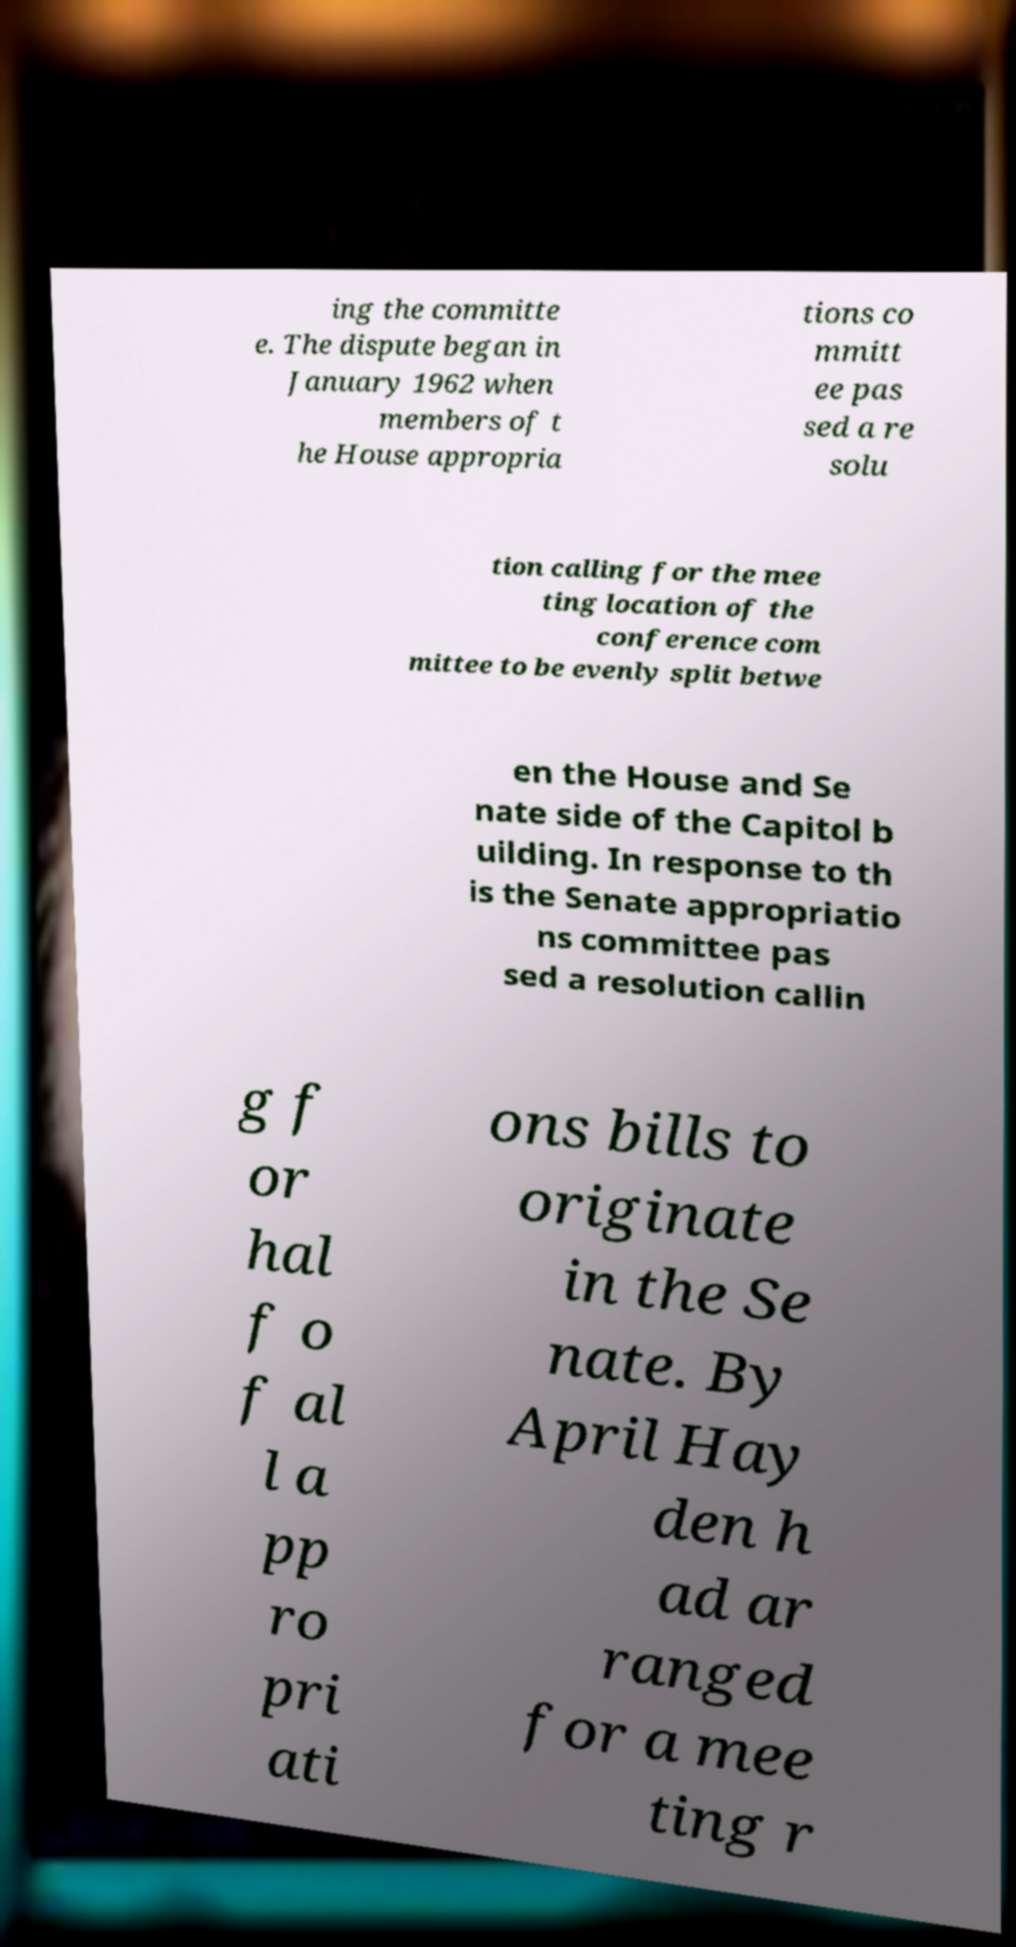There's text embedded in this image that I need extracted. Can you transcribe it verbatim? ing the committe e. The dispute began in January 1962 when members of t he House appropria tions co mmitt ee pas sed a re solu tion calling for the mee ting location of the conference com mittee to be evenly split betwe en the House and Se nate side of the Capitol b uilding. In response to th is the Senate appropriatio ns committee pas sed a resolution callin g f or hal f o f al l a pp ro pri ati ons bills to originate in the Se nate. By April Hay den h ad ar ranged for a mee ting r 